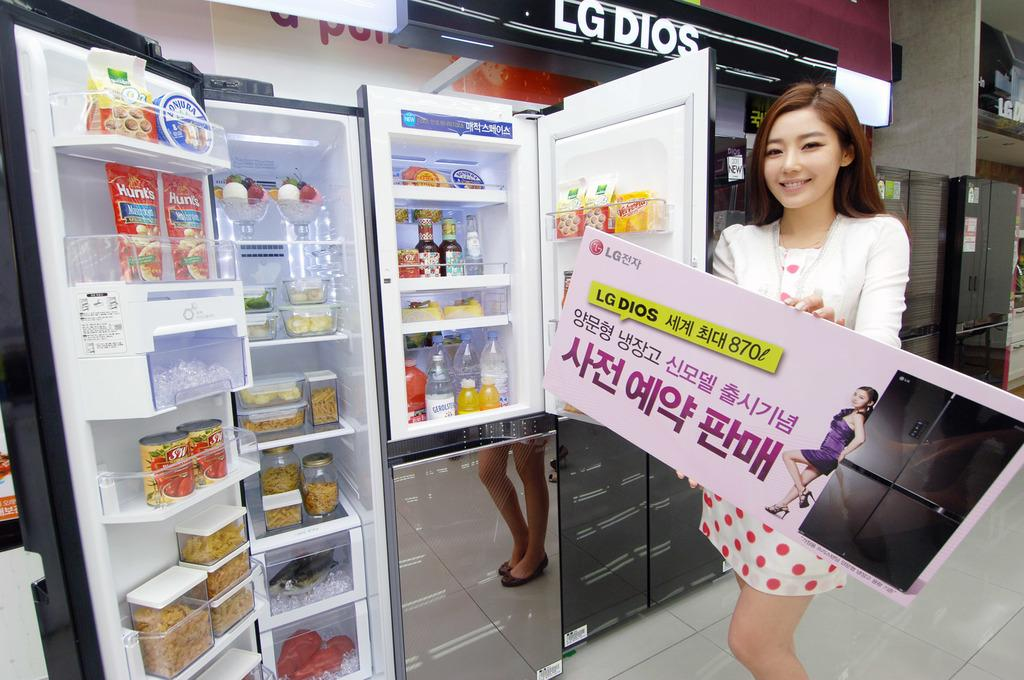<image>
Give a short and clear explanation of the subsequent image. A woman showing off a LG DIOS refrigerator. 